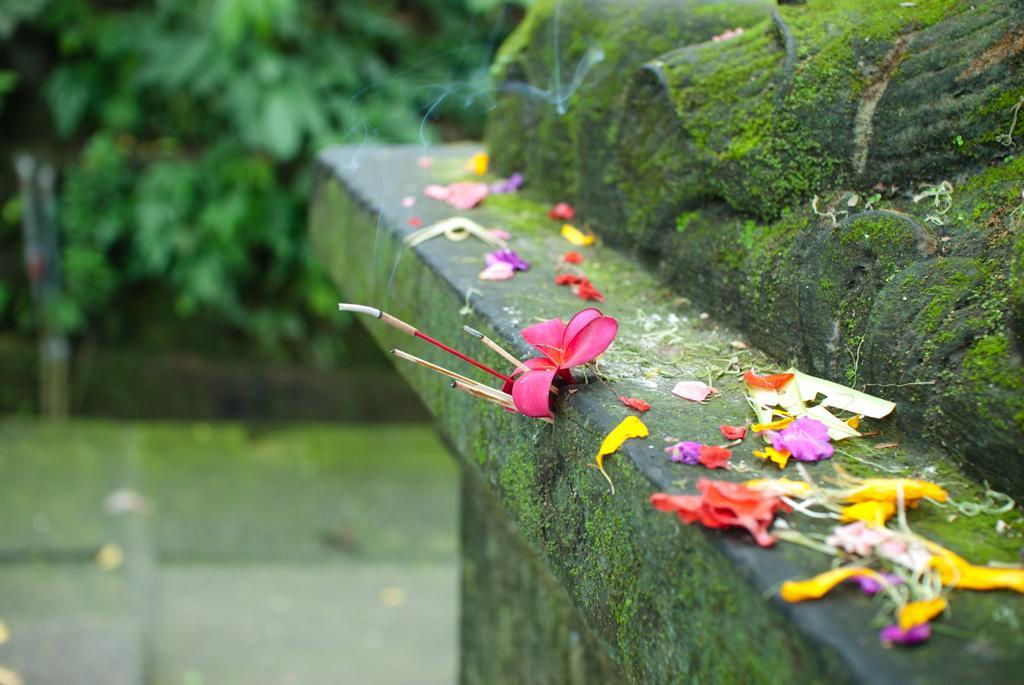Describe this image in one or two sentences. In this image I can see few flowers in pink, yellow and purple color. Backgrounds I can see few trees in green color and the flowers are on the wall. 